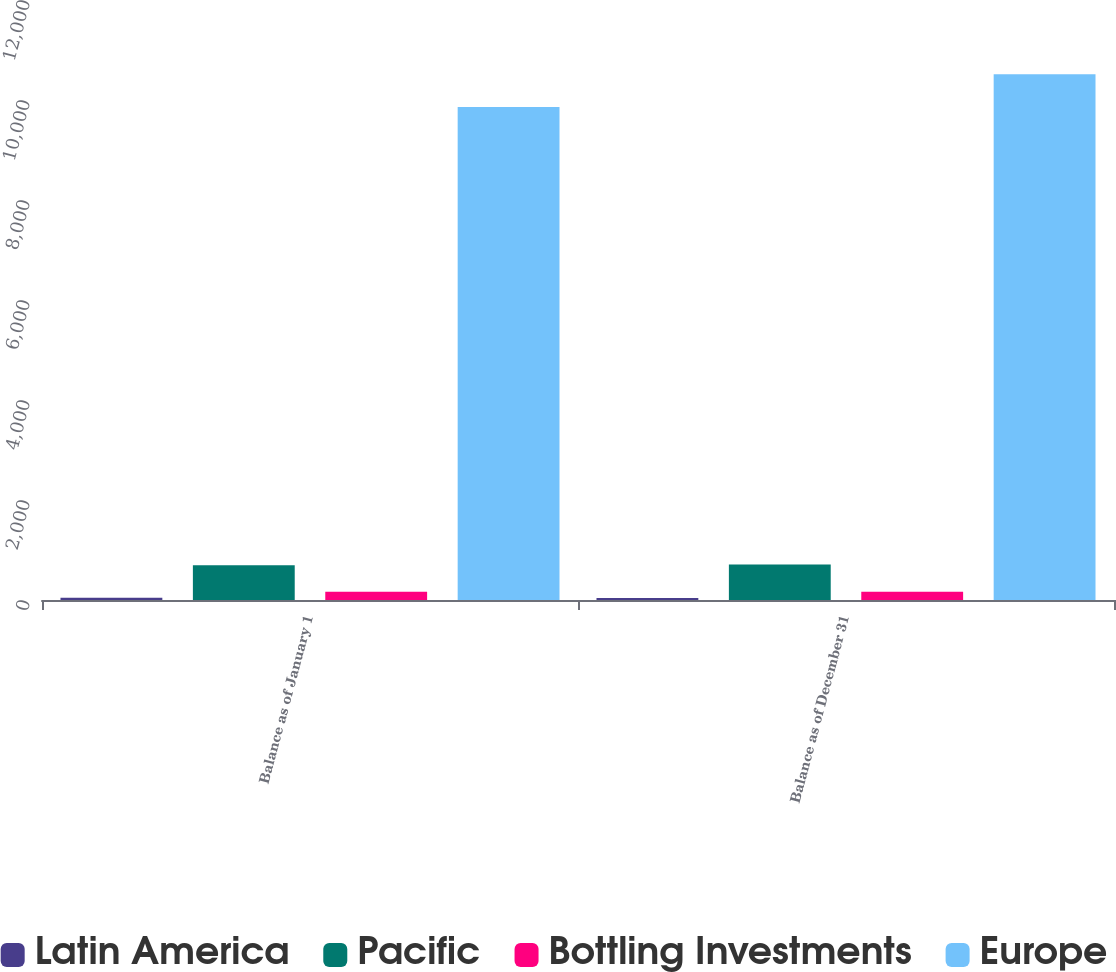<chart> <loc_0><loc_0><loc_500><loc_500><stacked_bar_chart><ecel><fcel>Balance as of January 1<fcel>Balance as of December 31<nl><fcel>Latin America<fcel>44<fcel>38<nl><fcel>Pacific<fcel>695<fcel>710<nl><fcel>Bottling Investments<fcel>166<fcel>163<nl><fcel>Europe<fcel>9861<fcel>10515<nl></chart> 